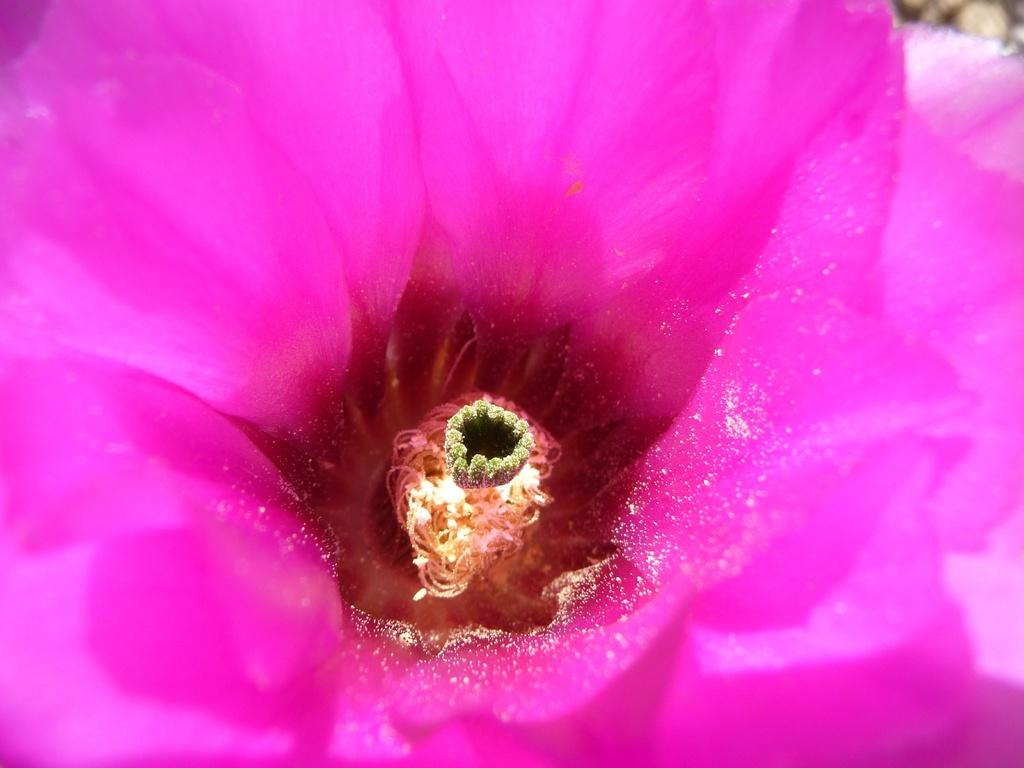What type of flower is in the image? There is a pink color flower in the image. Can you describe the background of the image? The background of the image is blurred. How many women are crossing the river in the image? There is no river or women present in the image; it features a pink color flower with a blurred background. What type of clam is visible on the flower in the image? There is no clam present on the flower in the image. 